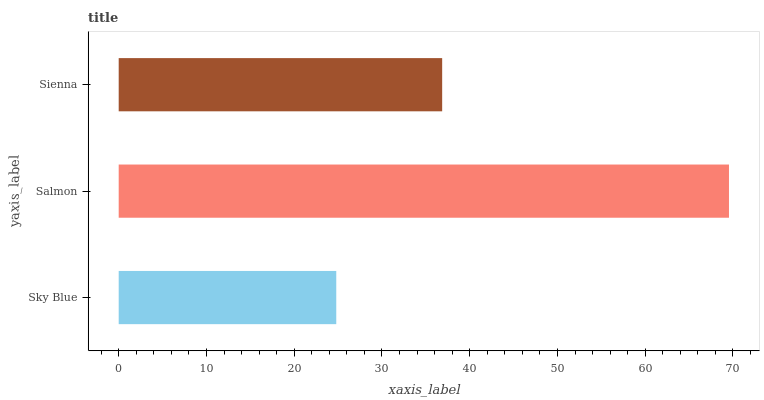Is Sky Blue the minimum?
Answer yes or no. Yes. Is Salmon the maximum?
Answer yes or no. Yes. Is Sienna the minimum?
Answer yes or no. No. Is Sienna the maximum?
Answer yes or no. No. Is Salmon greater than Sienna?
Answer yes or no. Yes. Is Sienna less than Salmon?
Answer yes or no. Yes. Is Sienna greater than Salmon?
Answer yes or no. No. Is Salmon less than Sienna?
Answer yes or no. No. Is Sienna the high median?
Answer yes or no. Yes. Is Sienna the low median?
Answer yes or no. Yes. Is Salmon the high median?
Answer yes or no. No. Is Salmon the low median?
Answer yes or no. No. 